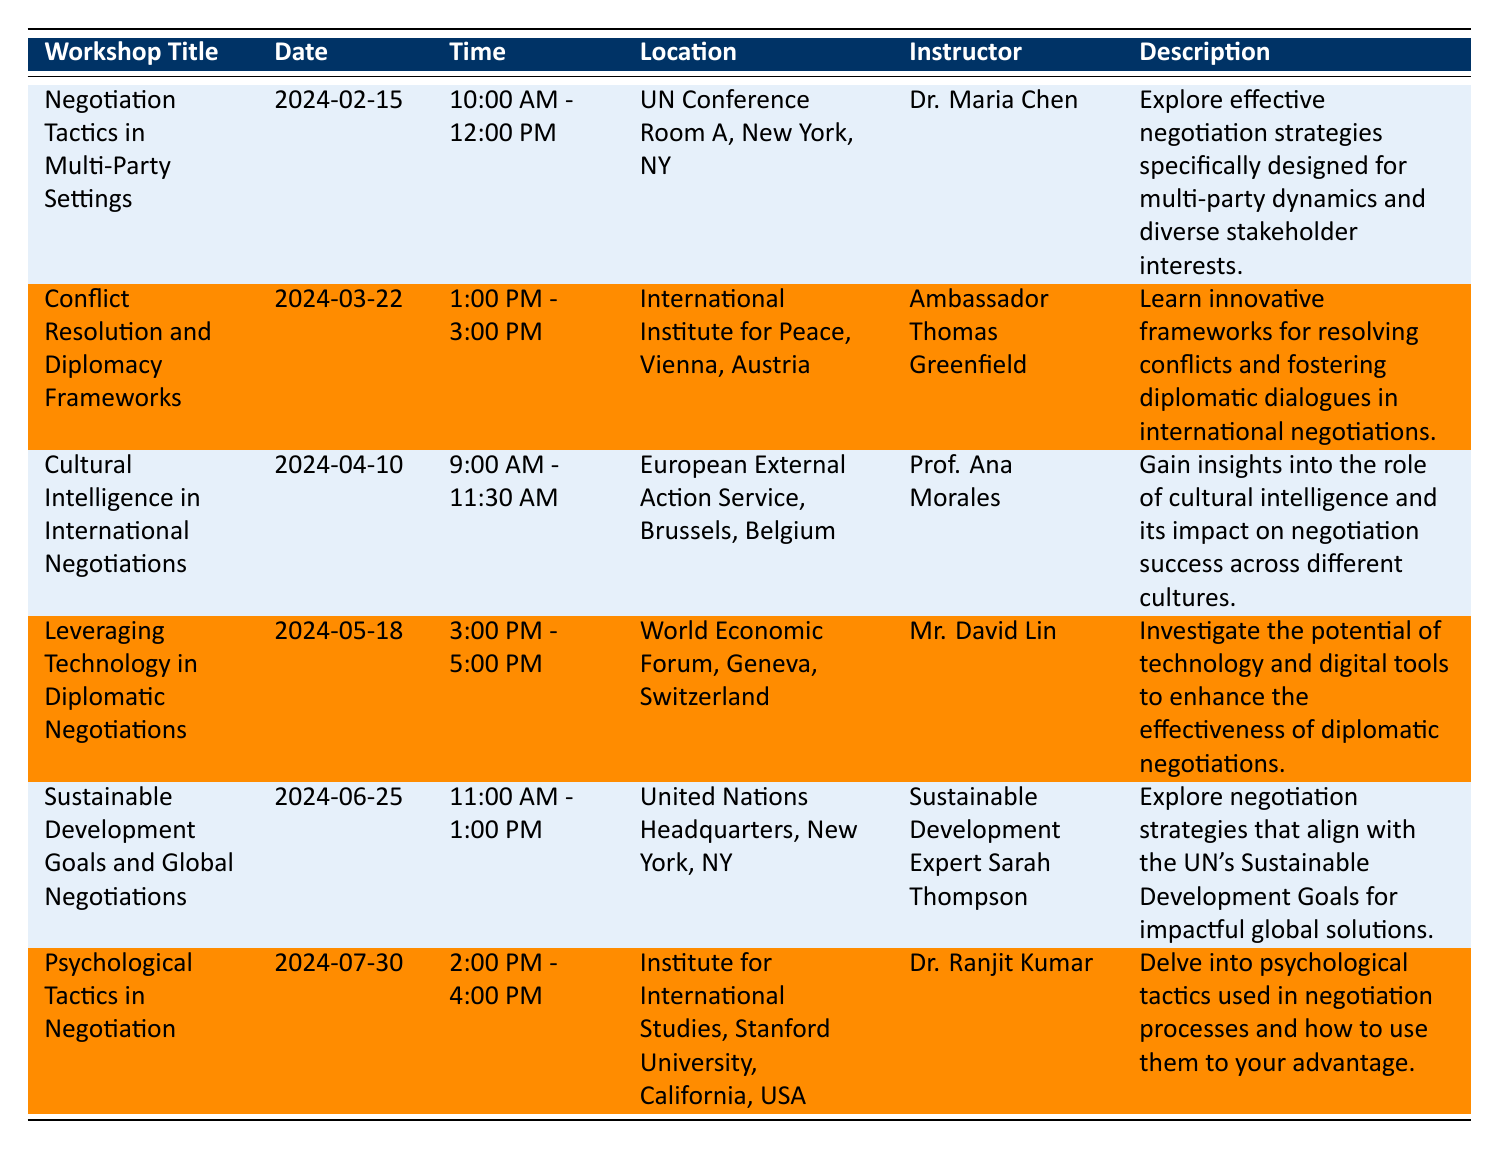What is the title of the workshop scheduled on March 22, 2024? The workshop scheduled on March 22, 2024, is titled "Conflict Resolution and Diplomacy Frameworks." This can be found directly in the "Workshop Title" column associated with the date "2024-03-22."
Answer: Conflict Resolution and Diplomacy Frameworks Who is the instructor for the workshop on Cultural Intelligence in International Negotiations? The instructor for the workshop titled "Cultural Intelligence in International Negotiations," which is scheduled for April 10, 2024, is Prof. Ana Morales. This information is found in the "Instructor" column corresponding to the respective workshop title.
Answer: Prof. Ana Morales How many workshops are held in New York City? There are three workshops held in New York City, as they are listed under the "Location" column with "New York, NY." The workshops are "Negotiation Tactics in Multi-Party Settings" (February 15), "Sustainable Development Goals and Global Negotiations" (June 25), and another one on "Sustainable Development Goals..." on the specified date.
Answer: 3 What is the time duration of the workshop led by Dr. Ranjit Kumar? The workshop led by Dr. Ranjit Kumar, titled "Psychological Tactics in Negotiation," has a time duration of 2 hours, running from 2:00 PM to 4:00 PM on July 30, 2024. The difference between the start time and the end time is calculated to find the duration.
Answer: 2 hours Which workshop is scheduled first and who is the instructor? The workshop scheduled first is "Negotiation Tactics in Multi-Party Settings," which will take place on February 15, 2024. The instructor for this workshop is Dr. Maria Chen. This can be determined by looking at the "Date" column and selecting the earliest date.
Answer: Negotiation Tactics in Multi-Party Settings, Dr. Maria Chen Is there a workshop focused on technological tools in negotiations? Yes, there is a workshop titled "Leveraging Technology in Diplomatic Negotiations" that focuses on technological tools in negotiations. This is clearly indicated in the description of the workshop.
Answer: Yes What is the common location for workshops related to the United Nations? The common location for workshops related to the UN is "United Nations Headquarters, New York, NY." This is indicated for the workshop on Sustainable Development Goals scheduled on June 25, and also mentioned in relation to other workshops listed at UN locations.
Answer: United Nations Headquarters, New York, NY How many workshops are scheduled after April 10, 2024? There are three workshops scheduled after April 10, 2024: "Leveraging Technology in Diplomatic Negotiations" (May 18), "Sustainable Development Goals and Global Negotiations" (June 25), and "Psychological Tactics in Negotiation" (July 30). This is determined by counting all workshops with a date greater than April 10 in the table.
Answer: 3 Which instructor has the longest workshop time slot based on the schedule? The longest time slot for a workshop is from 9:00 AM to 11:30 AM conducted by Prof. Ana Morales for the workshop "Cultural Intelligence in International Negotiations," providing a total duration of 2.5 hours, calculated from the start and end time on April 10, 2024.
Answer: Prof. Ana Morales, 2.5 hours 